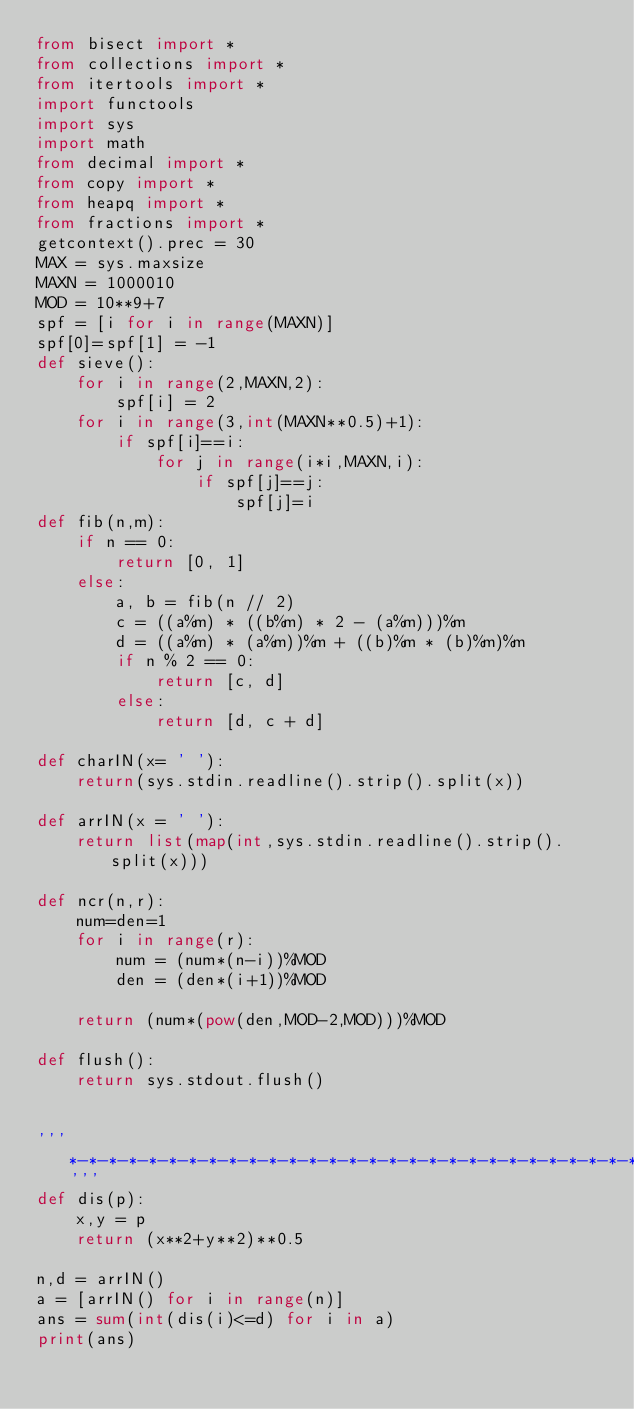Convert code to text. <code><loc_0><loc_0><loc_500><loc_500><_Python_>from bisect import *
from collections import *
from itertools import *
import functools
import sys
import math
from decimal import *
from copy import *
from heapq import *
from fractions import *
getcontext().prec = 30
MAX = sys.maxsize
MAXN = 1000010
MOD = 10**9+7
spf = [i for i in range(MAXN)]
spf[0]=spf[1] = -1
def sieve():
    for i in range(2,MAXN,2):
        spf[i] = 2
    for i in range(3,int(MAXN**0.5)+1):
        if spf[i]==i:
            for j in range(i*i,MAXN,i):
                if spf[j]==j:
                    spf[j]=i
def fib(n,m):
    if n == 0:
        return [0, 1]
    else:
        a, b = fib(n // 2)
        c = ((a%m) * ((b%m) * 2 - (a%m)))%m
        d = ((a%m) * (a%m))%m + ((b)%m * (b)%m)%m
        if n % 2 == 0:
            return [c, d]
        else:
            return [d, c + d]
 
def charIN(x= ' '):
    return(sys.stdin.readline().strip().split(x))
 
def arrIN(x = ' '):
    return list(map(int,sys.stdin.readline().strip().split(x)))
 
def ncr(n,r):
    num=den=1
    for i in range(r):
        num = (num*(n-i))%MOD
        den = (den*(i+1))%MOD
 
    return (num*(pow(den,MOD-2,MOD)))%MOD
 
def flush():
    return sys.stdout.flush()
 

'''*-*-*-*-*-*-*-*-*-*-*-*-*-*-*-*-*-*-*-*-*-*-*-*-*-*-*-*-*-*-*-*-*-*-*-*-*-*-*'''
def dis(p):
    x,y = p
    return (x**2+y**2)**0.5

n,d = arrIN()
a = [arrIN() for i in range(n)]
ans = sum(int(dis(i)<=d) for i in a)
print(ans)</code> 